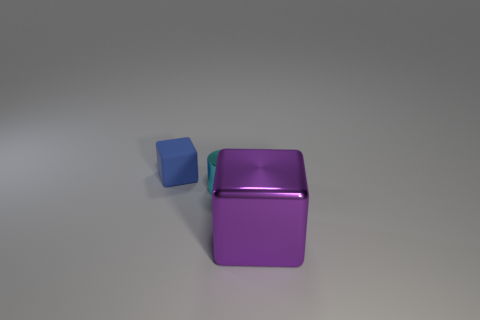Add 2 tiny cylinders. How many objects exist? 5 Subtract 1 cylinders. How many cylinders are left? 0 Subtract all cylinders. How many objects are left? 2 Subtract all green blocks. Subtract all blue cylinders. How many blocks are left? 2 Subtract all brown balls. How many blue blocks are left? 1 Subtract all matte cubes. Subtract all yellow shiny spheres. How many objects are left? 2 Add 2 tiny objects. How many tiny objects are left? 4 Add 3 small green matte spheres. How many small green matte spheres exist? 3 Subtract all purple cubes. How many cubes are left? 1 Subtract 0 yellow balls. How many objects are left? 3 